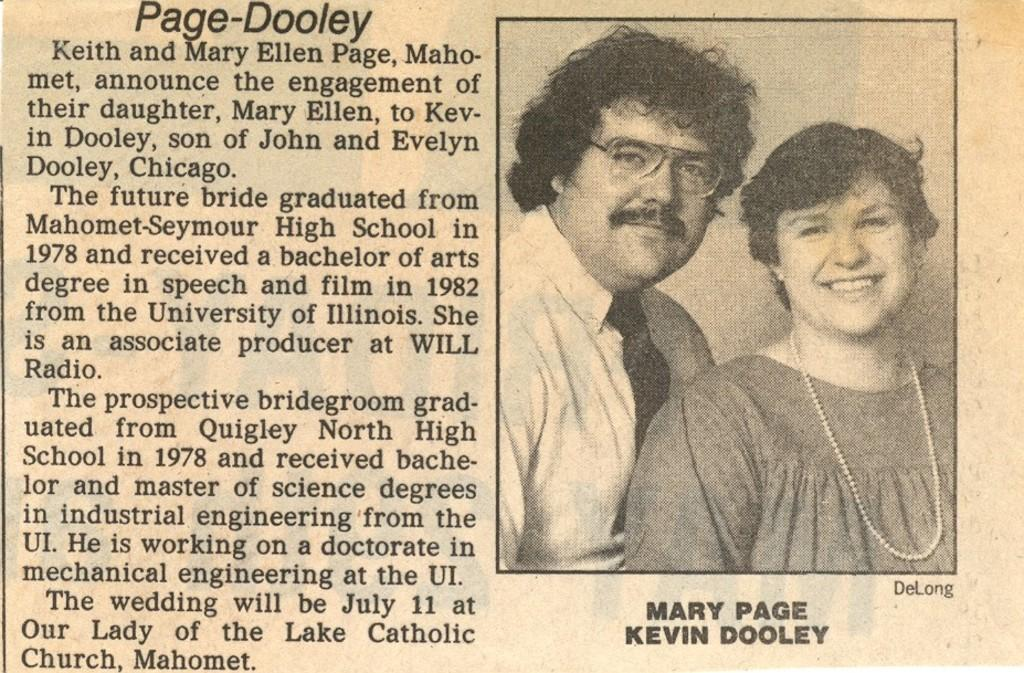What is present on the paper in the image? The paper contains text. How many people are in the image? There are two persons in the image. What are the two persons doing in the image? The two persons are standing and smiling. Can you see any cats playing with a hose in the image? There are no cats or hoses present in the image. 